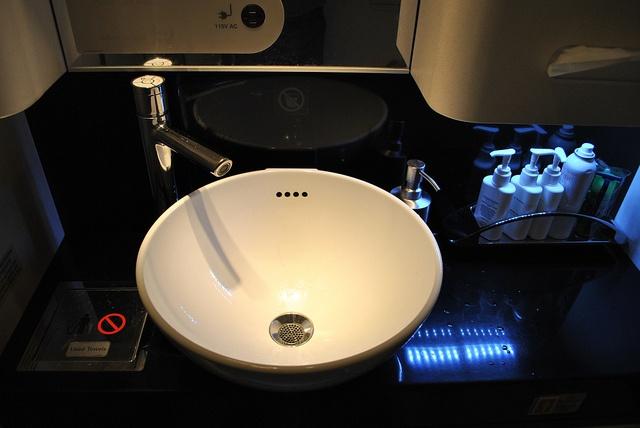Describe the objects in this image and their specific colors. I can see a sink in black, tan, and beige tones in this image. 